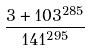Convert formula to latex. <formula><loc_0><loc_0><loc_500><loc_500>\frac { 3 + 1 0 3 ^ { 2 8 5 } } { 1 4 1 ^ { 2 9 5 } }</formula> 